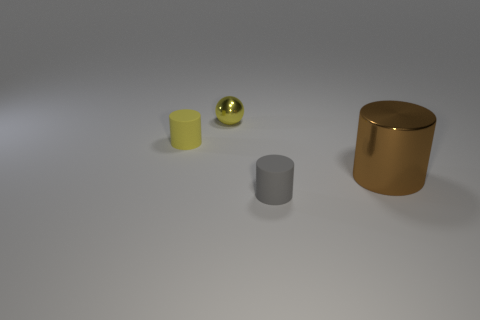What number of small green metal cylinders are there?
Provide a succinct answer. 0. There is a matte cylinder right of the tiny yellow metal object; what color is it?
Provide a succinct answer. Gray. The tiny matte object that is on the right side of the cylinder behind the shiny cylinder is what color?
Offer a terse response. Gray. What is the color of the metal sphere that is the same size as the gray object?
Keep it short and to the point. Yellow. What number of small matte objects are both in front of the brown cylinder and behind the brown metal cylinder?
Your response must be concise. 0. What is the material of the object that is behind the big brown shiny cylinder and in front of the yellow metallic ball?
Your response must be concise. Rubber. Are there fewer small yellow metallic balls right of the brown thing than gray matte objects that are in front of the gray rubber cylinder?
Make the answer very short. No. What size is the cylinder that is made of the same material as the ball?
Your answer should be compact. Large. Are there any other things of the same color as the tiny sphere?
Your answer should be compact. Yes. Does the gray thing have the same material as the object that is on the left side of the metallic sphere?
Make the answer very short. Yes. 